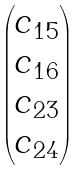Convert formula to latex. <formula><loc_0><loc_0><loc_500><loc_500>\begin{pmatrix} c _ { 1 5 } \\ c _ { 1 6 } \\ c _ { 2 3 } \\ c _ { 2 4 } \end{pmatrix}</formula> 